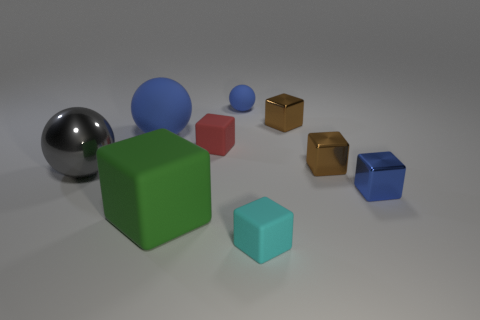Subtract all cyan blocks. How many blocks are left? 5 Subtract 1 balls. How many balls are left? 2 Subtract all green cubes. How many cubes are left? 5 Subtract all gray cubes. Subtract all purple spheres. How many cubes are left? 6 Subtract all spheres. How many objects are left? 6 Subtract all small red matte blocks. Subtract all brown objects. How many objects are left? 6 Add 3 small metallic blocks. How many small metallic blocks are left? 6 Add 2 tiny red rubber objects. How many tiny red rubber objects exist? 3 Subtract 0 purple cubes. How many objects are left? 9 